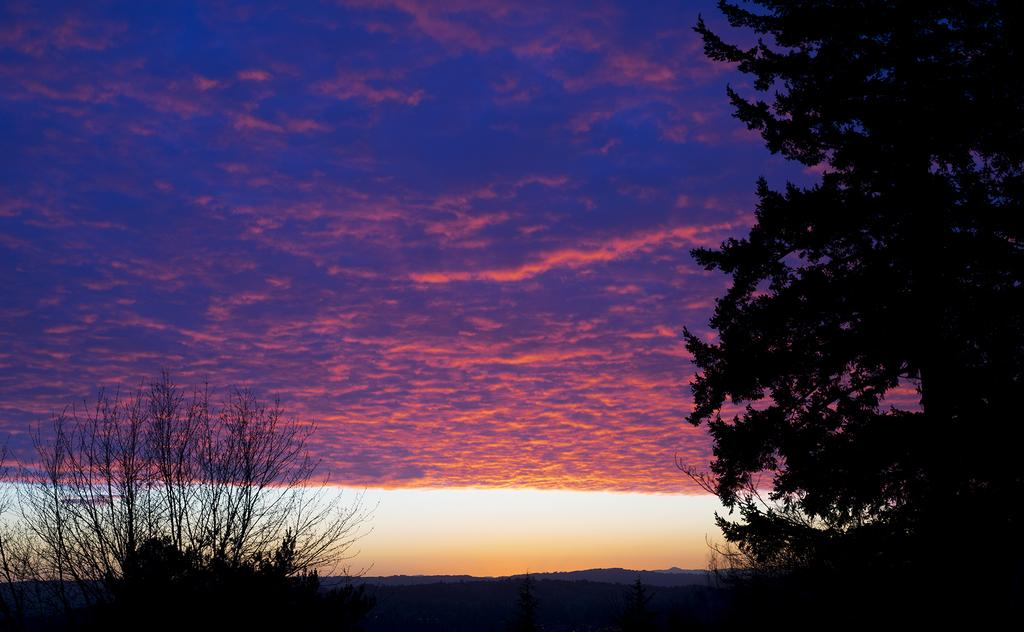What type of vegetation is present at the bottom and on the right side of the image? There are trees at the bottom and on the right side of the image. What type of natural landform can be seen in the background of the image? There are mountains in the background of the image. What is visible in the sky in the background of the image? There are clouds in the sky in the background of the image. What type of building can be seen in the image? There is no building present in the image; it features trees, mountains, and clouds. How many additions are there to the trees in the image? There are no additions to the trees in the image; the trees are the main focus in that area. 